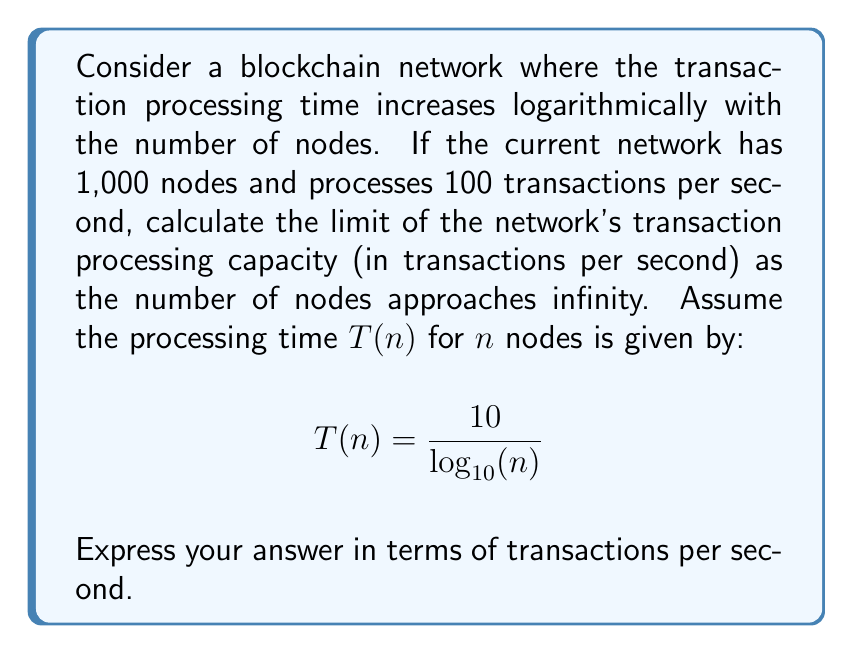Help me with this question. To solve this problem, we need to follow these steps:

1) First, let's establish the current transaction processing capacity:
   With 1,000 nodes, the processing time is:
   $$T(1000) = \frac{10}{\log_{10}(1000)} = \frac{10}{3} \text{ seconds}$$
   
   This results in 100 transactions per second.

2) Let's call the number of transactions processed per second $f(n)$. We can set up the following equation:
   $$f(n) \cdot T(n) = 100 \cdot \frac{10}{3}$$

3) Substituting the function for $T(n)$:
   $$f(n) \cdot \frac{10}{\log_{10}(n)} = \frac{1000}{3}$$

4) Solving for $f(n)$:
   $$f(n) = \frac{1000}{3} \cdot \frac{\log_{10}(n)}{10} = \frac{100}{3} \log_{10}(n)$$

5) Now, we need to find the limit of this function as $n$ approaches infinity:
   $$\lim_{n \to \infty} f(n) = \lim_{n \to \infty} \frac{100}{3} \log_{10}(n)$$

6) The logarithm function grows without bound as $n$ approaches infinity, but it grows very slowly. The limit of $\log_{10}(n)$ as $n$ approaches infinity is infinity.

7) Therefore:
   $$\lim_{n \to \infty} f(n) = \infty$$

This means that as the number of nodes in the network approaches infinity, the transaction processing capacity also approaches infinity, but at a logarithmic rate.
Answer: The limit of the network's transaction processing capacity as the number of nodes approaches infinity is $\infty$ transactions per second. 